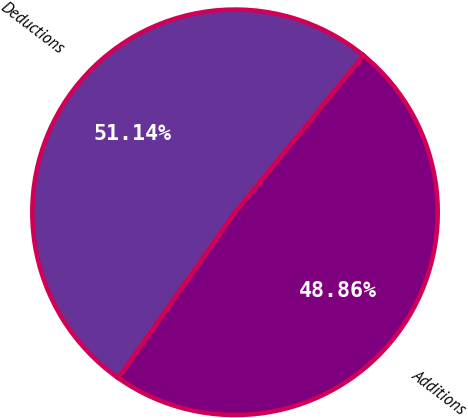<chart> <loc_0><loc_0><loc_500><loc_500><pie_chart><fcel>Additions<fcel>Deductions<nl><fcel>48.86%<fcel>51.14%<nl></chart> 